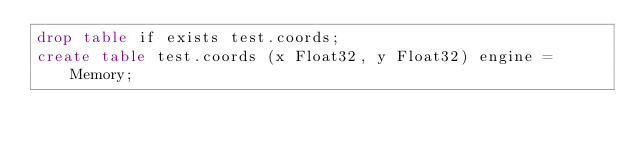Convert code to text. <code><loc_0><loc_0><loc_500><loc_500><_SQL_>drop table if exists test.coords;
create table test.coords (x Float32, y Float32) engine = Memory;</code> 